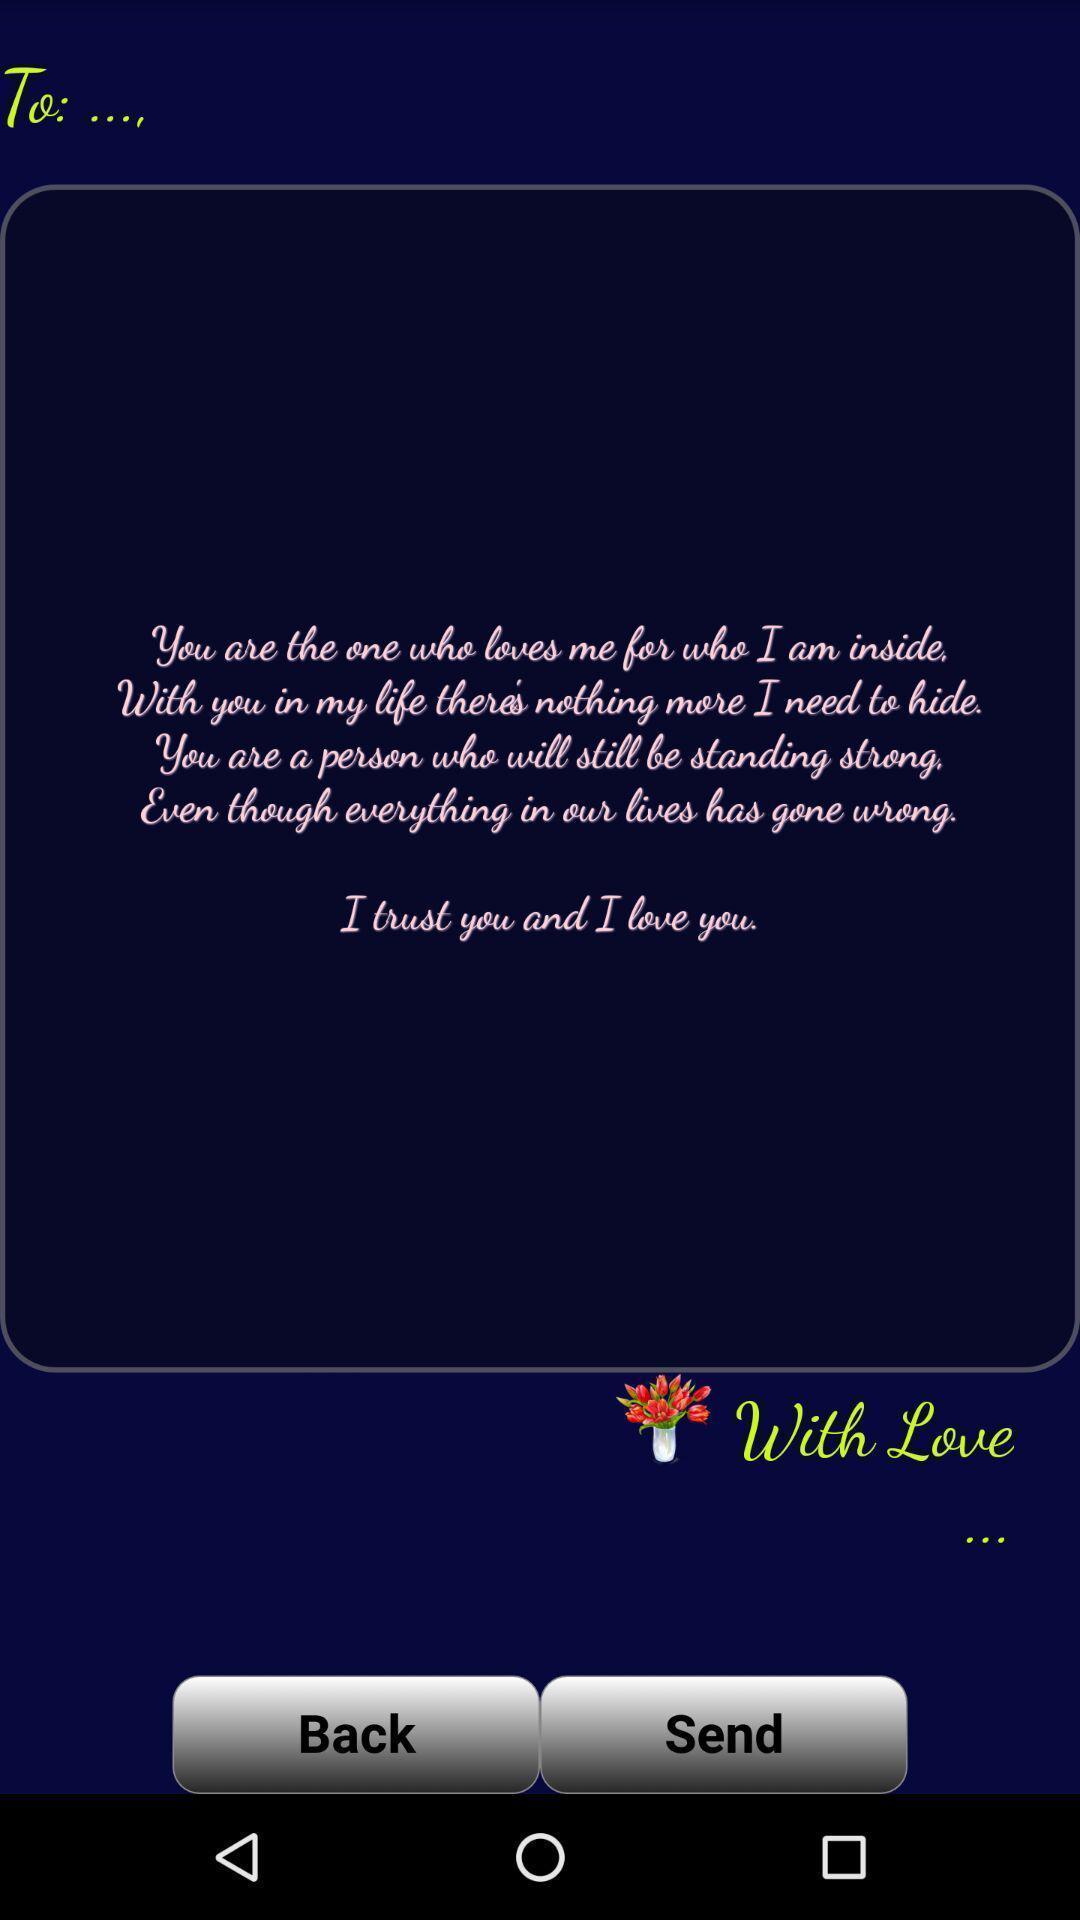Describe the visual elements of this screenshot. Page displaying image with options like send back. 